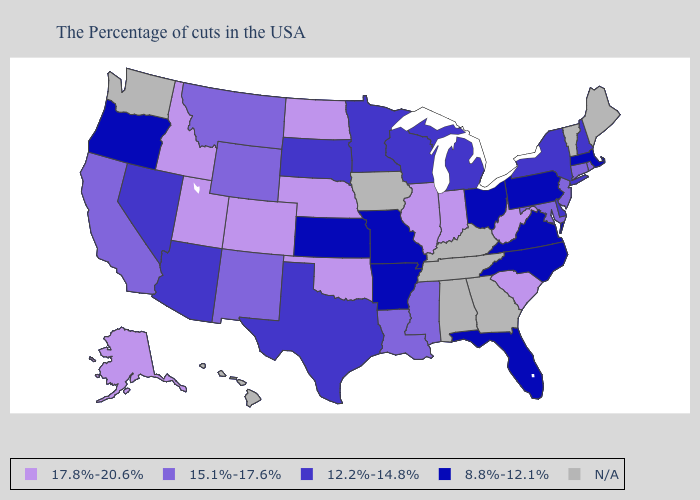Among the states that border Washington , which have the highest value?
Answer briefly. Idaho. Name the states that have a value in the range 15.1%-17.6%?
Short answer required. Rhode Island, Connecticut, New Jersey, Maryland, Mississippi, Louisiana, Wyoming, New Mexico, Montana, California. What is the value of Colorado?
Quick response, please. 17.8%-20.6%. Among the states that border New York , does New Jersey have the highest value?
Quick response, please. Yes. What is the lowest value in the West?
Be succinct. 8.8%-12.1%. Among the states that border New Jersey , does Delaware have the lowest value?
Concise answer only. No. What is the highest value in states that border South Carolina?
Write a very short answer. 8.8%-12.1%. Name the states that have a value in the range N/A?
Keep it brief. Maine, Vermont, Georgia, Kentucky, Alabama, Tennessee, Iowa, Washington, Hawaii. What is the value of South Dakota?
Keep it brief. 12.2%-14.8%. What is the value of Connecticut?
Short answer required. 15.1%-17.6%. Among the states that border New Hampshire , which have the highest value?
Write a very short answer. Massachusetts. What is the value of North Dakota?
Give a very brief answer. 17.8%-20.6%. Among the states that border Kentucky , which have the lowest value?
Quick response, please. Virginia, Ohio, Missouri. What is the highest value in states that border Nebraska?
Write a very short answer. 17.8%-20.6%. 